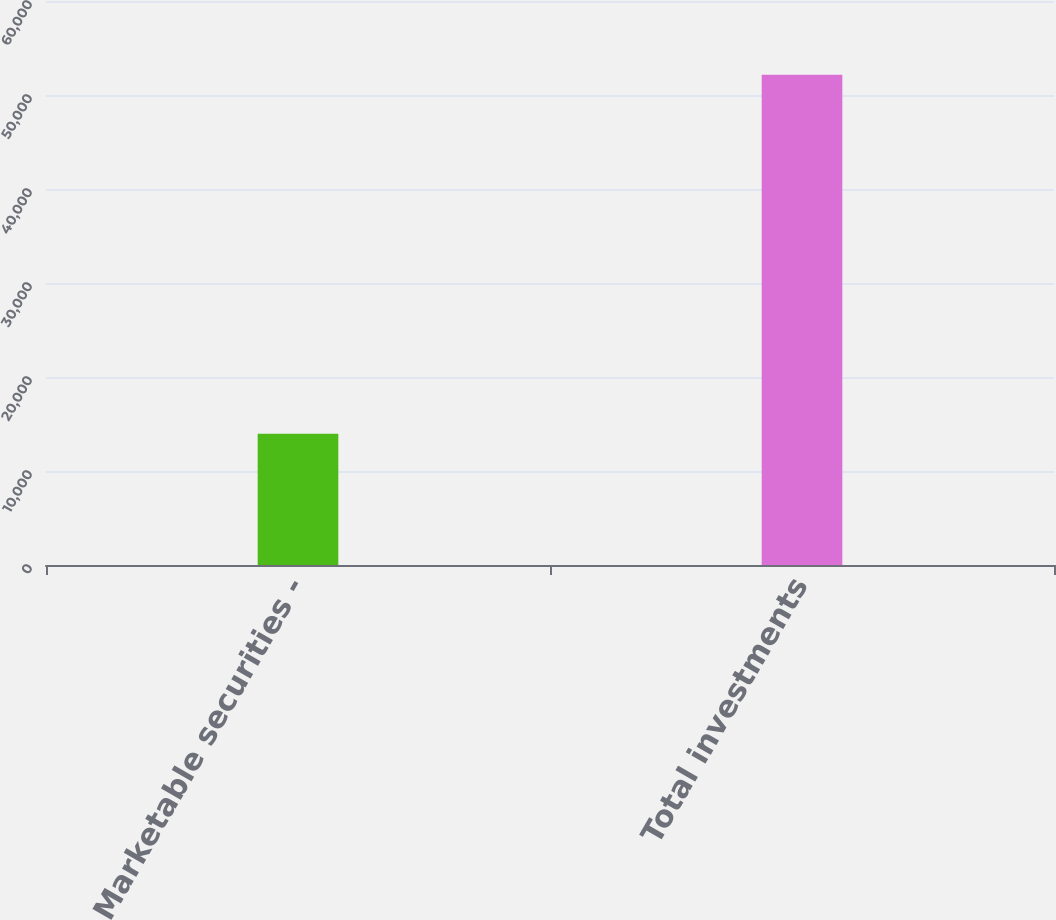<chart> <loc_0><loc_0><loc_500><loc_500><bar_chart><fcel>Marketable securities -<fcel>Total investments<nl><fcel>13974<fcel>52150<nl></chart> 